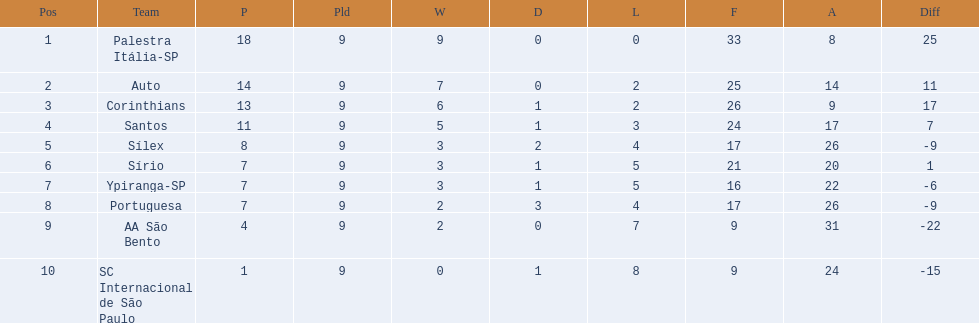What were all the teams that competed in 1926 brazilian football? Palestra Itália-SP, Auto, Corinthians, Santos, Sílex, Sírio, Ypiranga-SP, Portuguesa, AA São Bento, SC Internacional de São Paulo. Which of these had zero games lost? Palestra Itália-SP. 